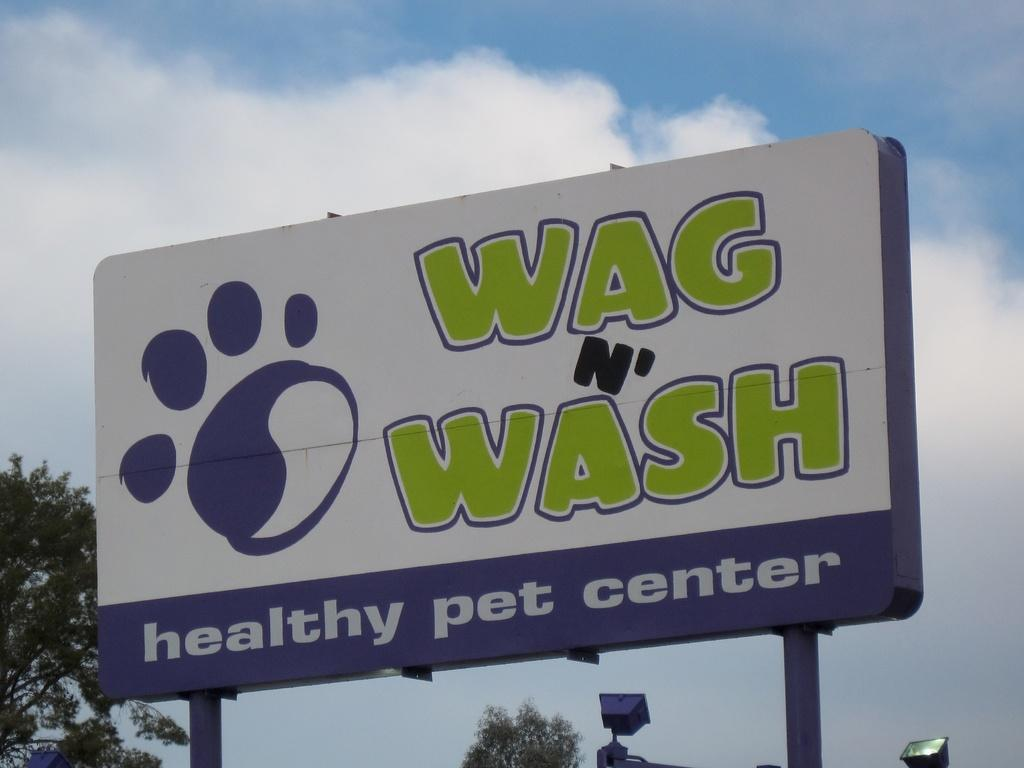<image>
Write a terse but informative summary of the picture. A billboard for a healthy pet center features green and white text. 